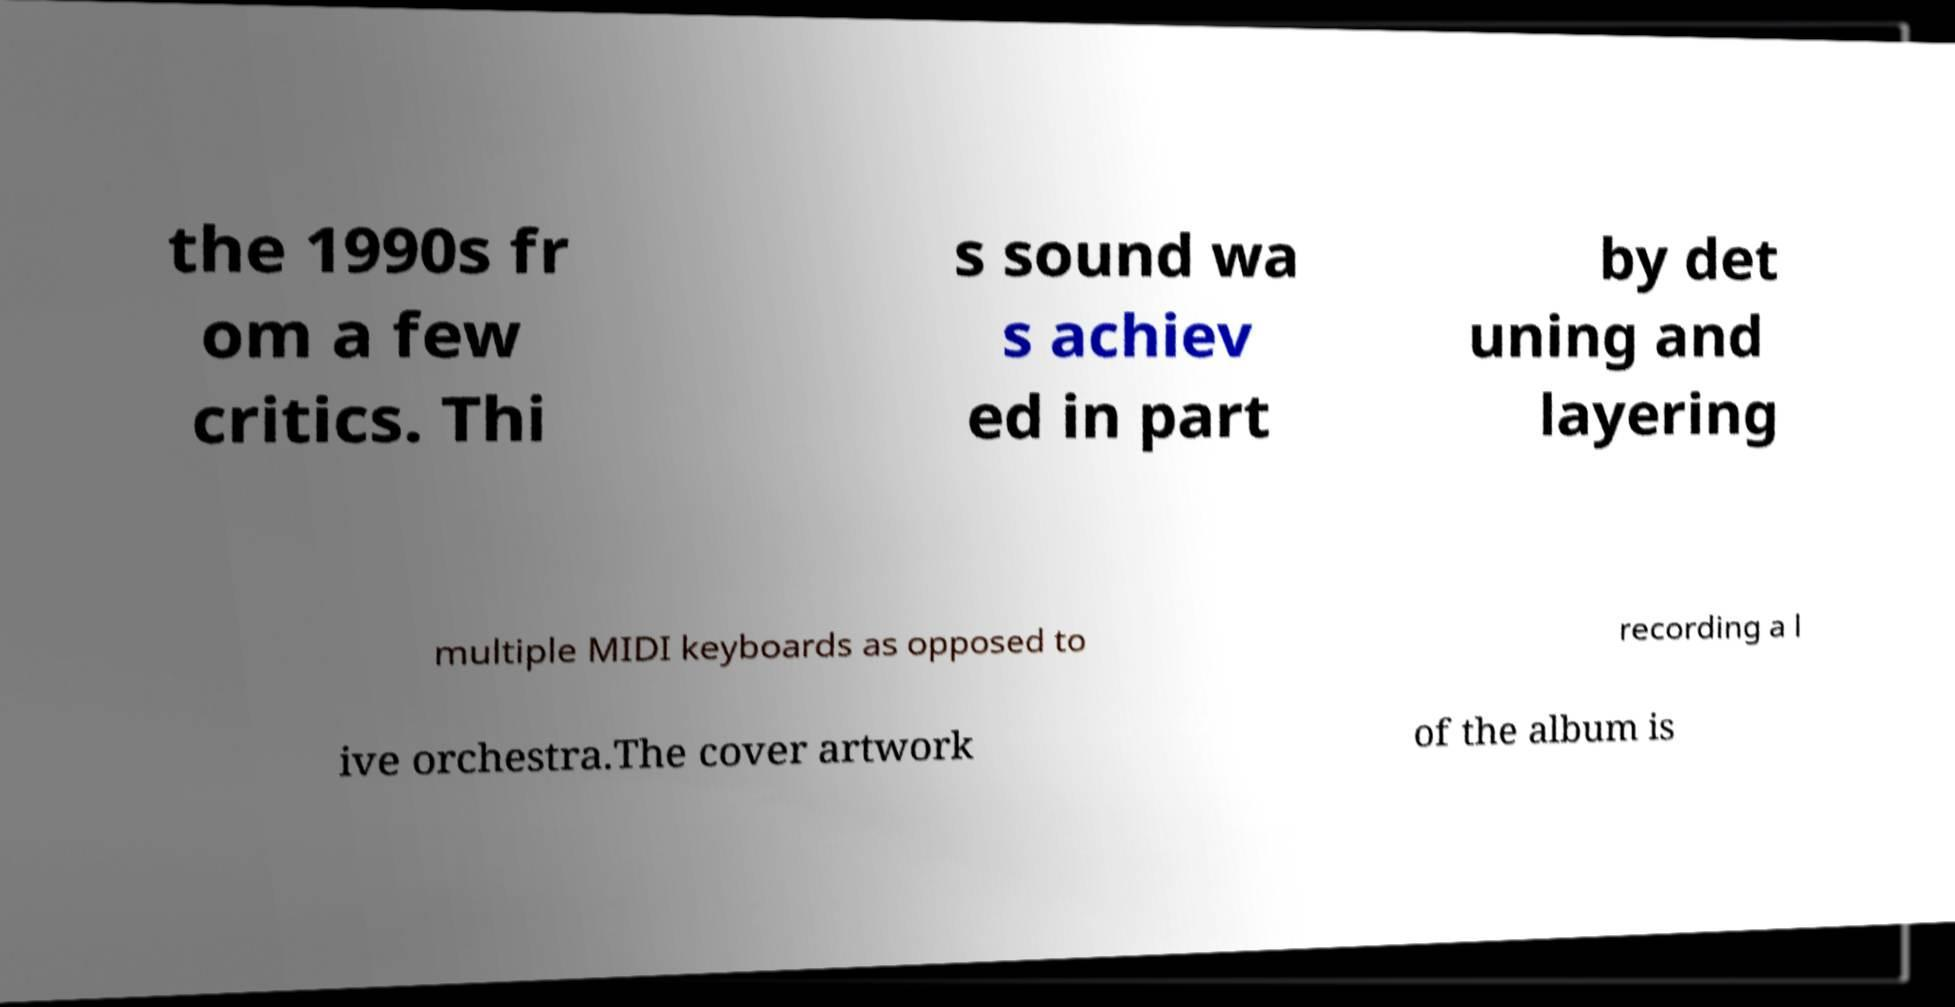Could you assist in decoding the text presented in this image and type it out clearly? the 1990s fr om a few critics. Thi s sound wa s achiev ed in part by det uning and layering multiple MIDI keyboards as opposed to recording a l ive orchestra.The cover artwork of the album is 